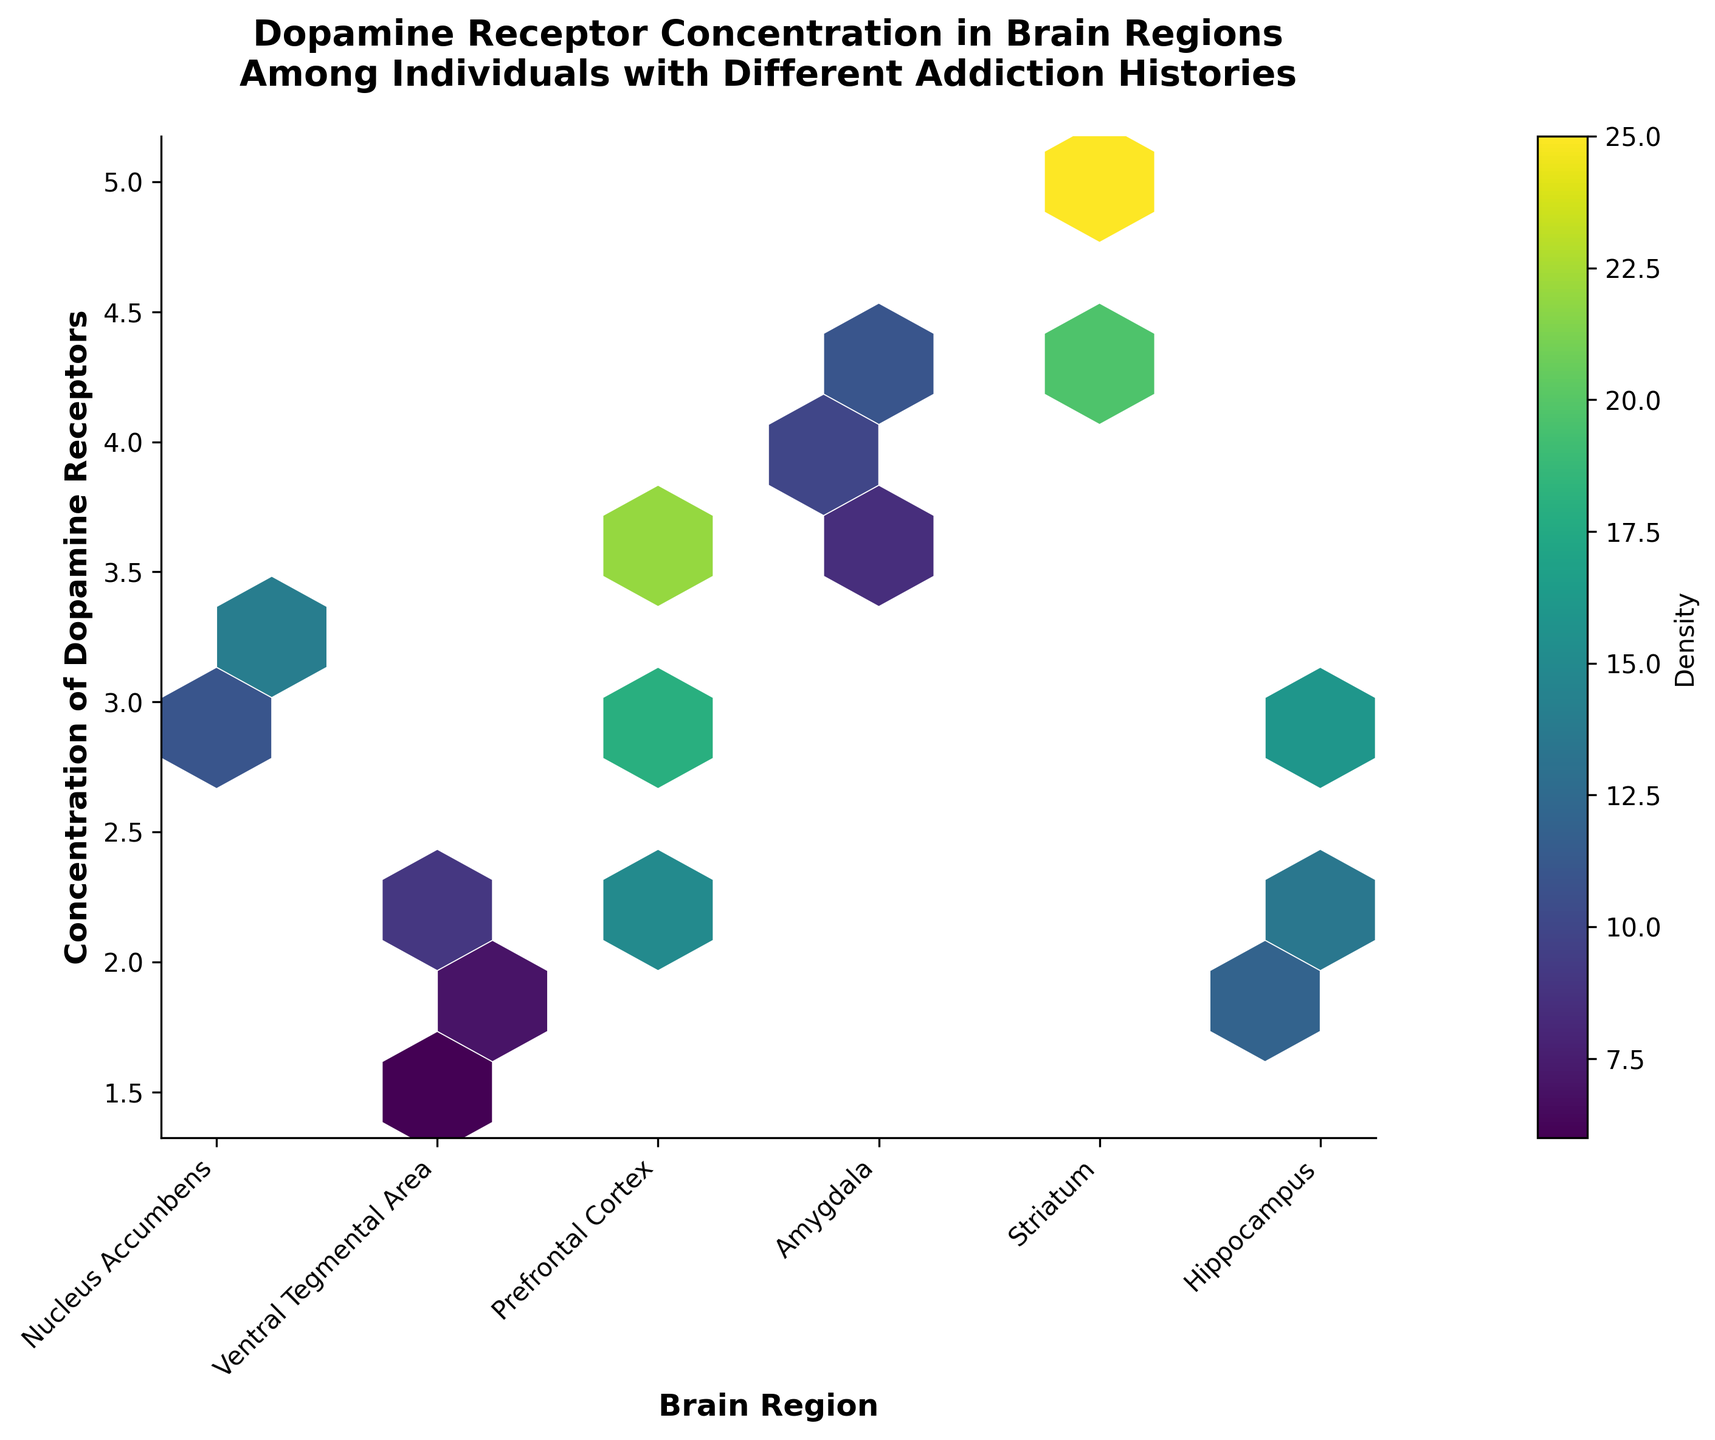What is the title of the plot? The title is displayed at the top of the figure. It reads: "Dopamine Receptor Concentration in Brain Regions Among Individuals with Different Addiction Histories".
Answer: Dopamine Receptor Concentration in Brain Regions Among Individuals with Different Addiction Histories What does the color represent in the hexbin plot? The color represents the density of dopamine receptors in each hexagonal bin on the plot.
Answer: Density Which brain region shows the highest concentration of dopamine receptors? Look for the brain region on the x-axis that has hexbin cells with the highest y-values. The Striatum has hexagonal bins with higher y-values.
Answer: Striatum How many unique brain regions are presented in the plot? Count the number of unique labels on the x-axis. The labels are: Nucleus Accumbens, Ventral Tegmental Area, Prefrontal Cortex, Amygdala, Striatum, and Hippocampus.
Answer: 6 Which brain region has the highest density of dopamine receptors? Look for the hexagonal bin with the most intense color (darkest) and identify its corresponding x-axis label. The Striatum has the darkest bins, indicating the highest density.
Answer: Striatum What is the range of concentrations for the Prefrontal Cortex in the plot? Identify the hexagonal bins under the label "Prefrontal Cortex" and note the minimum and maximum y-values they cover. The bins range from approximately 3.5 to 4.2.
Answer: 3.5 to 4.2 Which brain region has the lowest average concentration of dopamine receptors? Compare the average positions of the hexagonal bins (y-values) for all brain regions. The Hippocampus is generally positioned lower on the y-axis compared to the other regions.
Answer: Hippocampus Which two brain regions have a similar range of dopamine receptor concentrations? Compare the y-ranges of the hexagonal bins for each brain region. The Nucleus Accumbens and Amygdala both have a similar range approximately from 2.3 to 3.8 and 2.7 to 3.3 respectively.
Answer: Nucleus Accumbens and Amygdala How does the density vary across different brain regions? Observe the color intensities of the hexagonal bins corresponding to each brain region. The Striatum has the highest density, with darker bins, followed by the Nucleus Accumbens. Other regions like the Hippocampus have lighter bins, indicating lower density.
Answer: Striatum has the highest density, followed by Nucleus Accumbens, with Hippocampus having the lowest Which brain region shows the widest variation in dopamine receptor concentration? Identify the brain region with the widest spread of y-values in the hexagonal bins. The Nucleus Accumbens ranges from approximately 2.3 to 3.8, showing the widest variation.
Answer: Nucleus Accumbens 